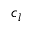<formula> <loc_0><loc_0><loc_500><loc_500>c _ { l }</formula> 